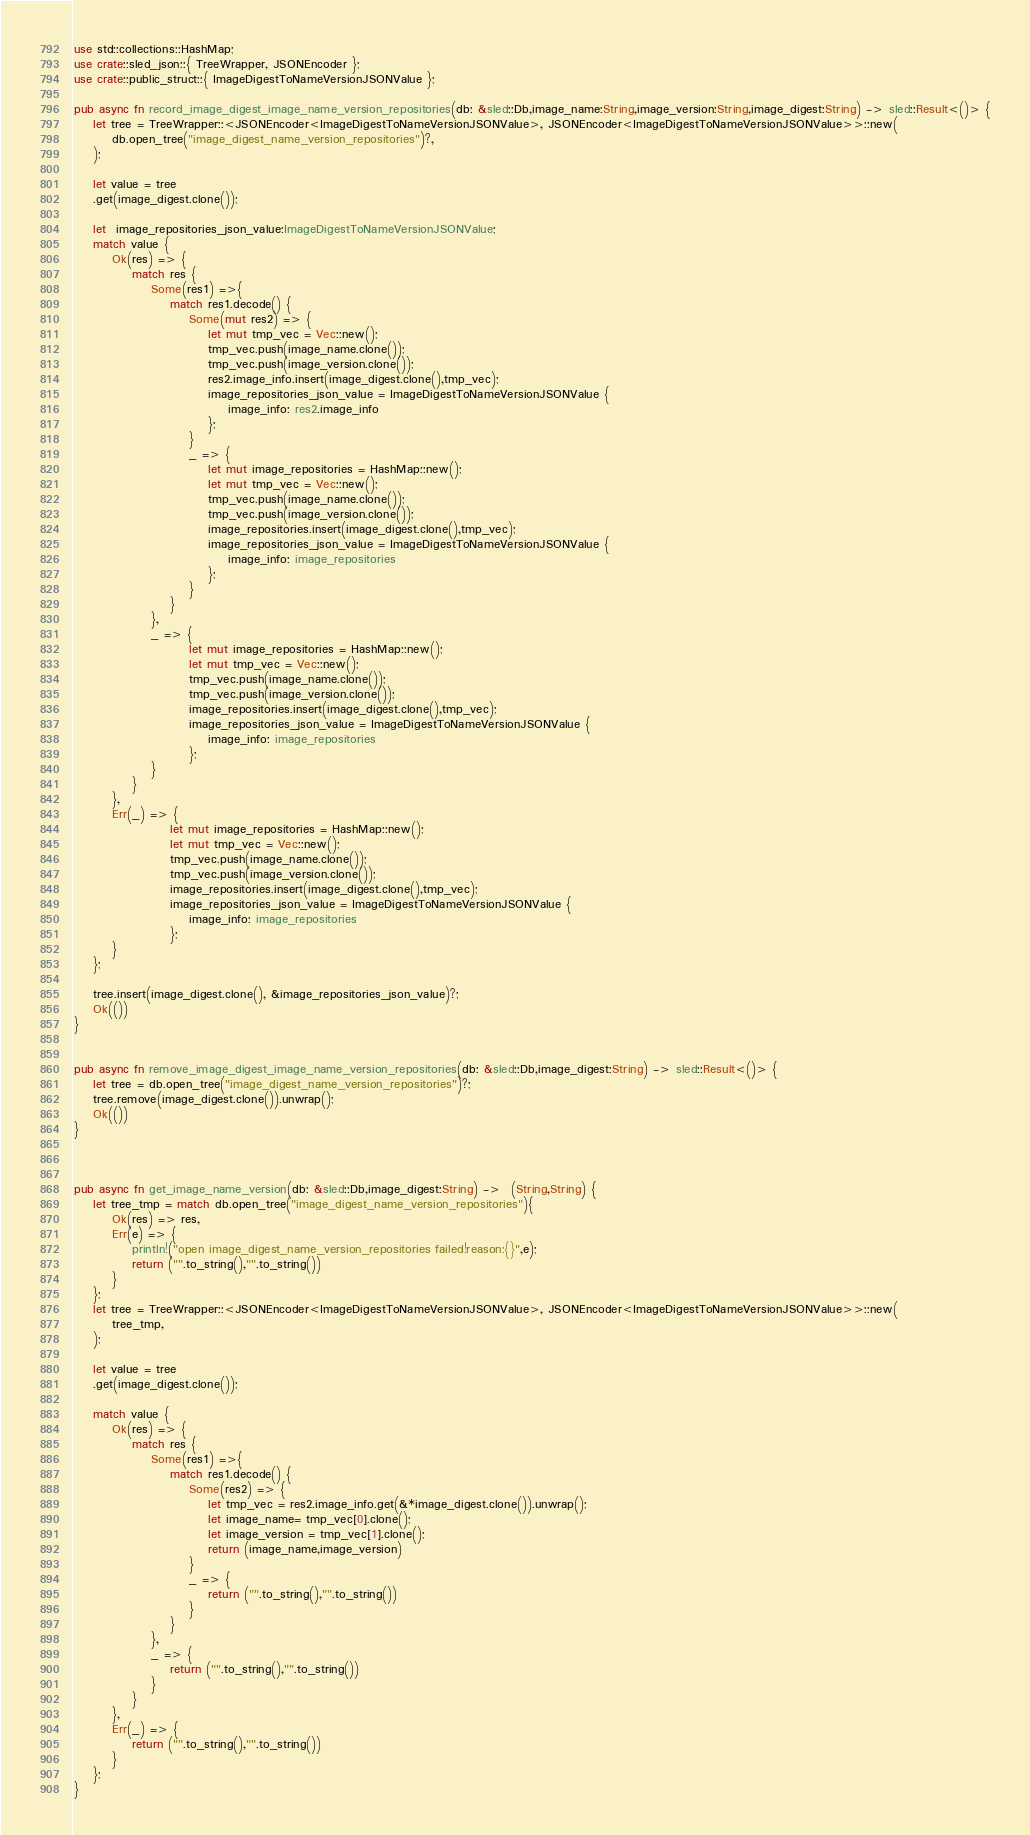<code> <loc_0><loc_0><loc_500><loc_500><_Rust_>use std::collections::HashMap;
use crate::sled_json::{ TreeWrapper, JSONEncoder };
use crate::public_struct::{ ImageDigestToNameVersionJSONValue };

pub async fn record_image_digest_image_name_version_repositories(db: &sled::Db,image_name:String,image_version:String,image_digest:String) -> sled::Result<()> {
    let tree = TreeWrapper::<JSONEncoder<ImageDigestToNameVersionJSONValue>, JSONEncoder<ImageDigestToNameVersionJSONValue>>::new(
        db.open_tree("image_digest_name_version_repositories")?,
    );

    let value = tree
    .get(image_digest.clone());

    let  image_repositories_json_value:ImageDigestToNameVersionJSONValue;
    match value {
        Ok(res) => {
            match res {
                Some(res1) =>{
                    match res1.decode() {
                        Some(mut res2) => {
                            let mut tmp_vec = Vec::new();
                            tmp_vec.push(image_name.clone());
                            tmp_vec.push(image_version.clone());
                            res2.image_info.insert(image_digest.clone(),tmp_vec);
                            image_repositories_json_value = ImageDigestToNameVersionJSONValue {
                                image_info: res2.image_info
                            };
                        }
                        _ => {
                            let mut image_repositories = HashMap::new();
                            let mut tmp_vec = Vec::new();
                            tmp_vec.push(image_name.clone());
                            tmp_vec.push(image_version.clone());
                            image_repositories.insert(image_digest.clone(),tmp_vec);
                            image_repositories_json_value = ImageDigestToNameVersionJSONValue {
                                image_info: image_repositories
                            };
                        }
                    }
                },
                _ => {
                        let mut image_repositories = HashMap::new();
                        let mut tmp_vec = Vec::new();
                        tmp_vec.push(image_name.clone());
                        tmp_vec.push(image_version.clone());
                        image_repositories.insert(image_digest.clone(),tmp_vec);
                        image_repositories_json_value = ImageDigestToNameVersionJSONValue {
                            image_info: image_repositories
                        };
                }
            }
        },
        Err(_) => {
                    let mut image_repositories = HashMap::new();
                    let mut tmp_vec = Vec::new();
                    tmp_vec.push(image_name.clone());
                    tmp_vec.push(image_version.clone());
                    image_repositories.insert(image_digest.clone(),tmp_vec);
                    image_repositories_json_value = ImageDigestToNameVersionJSONValue {
                        image_info: image_repositories
                    };
        }
    };

    tree.insert(image_digest.clone(), &image_repositories_json_value)?;
    Ok(())
}


pub async fn remove_image_digest_image_name_version_repositories(db: &sled::Db,image_digest:String) -> sled::Result<()> {
    let tree = db.open_tree("image_digest_name_version_repositories")?;
    tree.remove(image_digest.clone()).unwrap();
    Ok(())
}



pub async fn get_image_name_version(db: &sled::Db,image_digest:String) ->  (String,String) {
    let tree_tmp = match db.open_tree("image_digest_name_version_repositories"){
        Ok(res) => res,
        Err(e) => {
            println!("open image_digest_name_version_repositories failed!reason:{}",e);
            return ("".to_string(),"".to_string())
        }
    };
    let tree = TreeWrapper::<JSONEncoder<ImageDigestToNameVersionJSONValue>, JSONEncoder<ImageDigestToNameVersionJSONValue>>::new(
        tree_tmp,
    );

    let value = tree
    .get(image_digest.clone());

    match value {
        Ok(res) => {
            match res {
                Some(res1) =>{
                    match res1.decode() {
                        Some(res2) => {
                            let tmp_vec = res2.image_info.get(&*image_digest.clone()).unwrap();
                            let image_name= tmp_vec[0].clone();
                            let image_version = tmp_vec[1].clone();
                            return (image_name,image_version)
                        }
                        _ => {
                            return ("".to_string(),"".to_string())
                        }
                    }
                },
                _ => {
                    return ("".to_string(),"".to_string())
                }
            }
        },
        Err(_) => {
            return ("".to_string(),"".to_string())
        }
    };
}</code> 